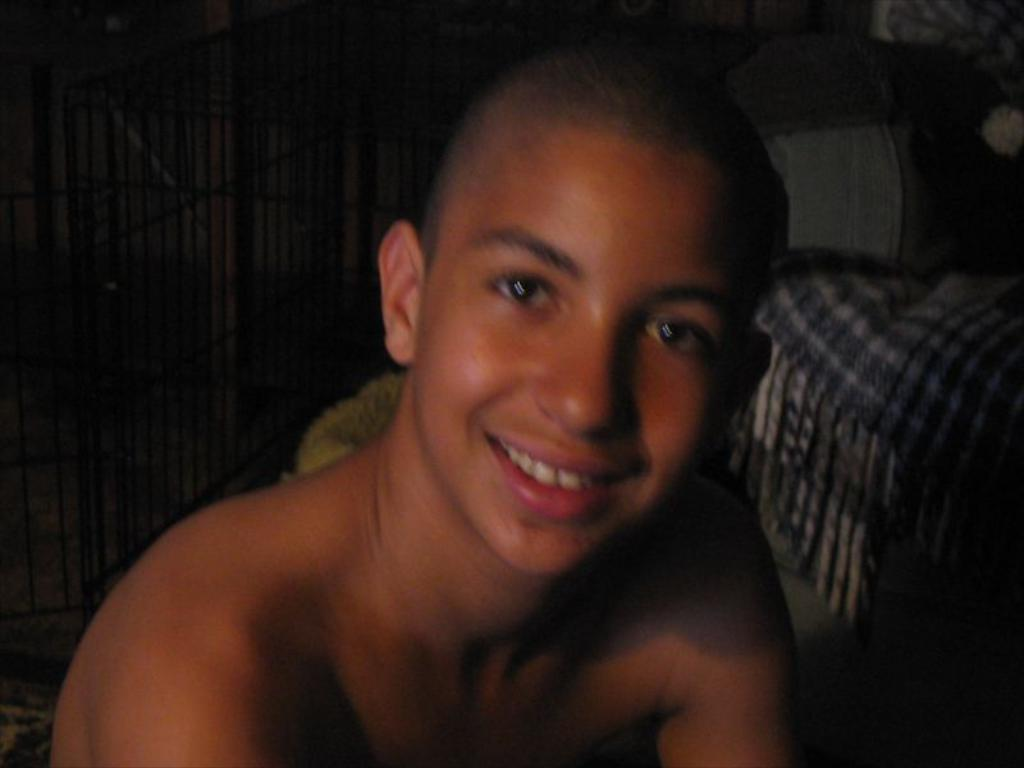What is present in the image? There is a person in the image. How is the person's expression in the image? The person is smiling. What else can be seen in the image besides the person? There are objects in the image. What type of barrier is visible in the image? There is a fence visible in the image. What type of dress is the horse wearing in the image? There is no horse present in the image, and therefore no dress for a horse to wear. 